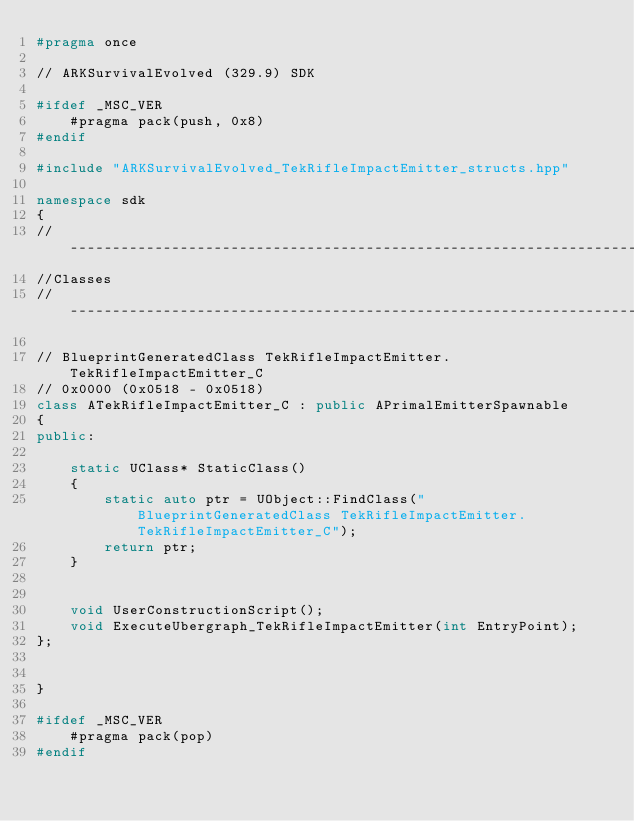Convert code to text. <code><loc_0><loc_0><loc_500><loc_500><_C++_>#pragma once

// ARKSurvivalEvolved (329.9) SDK

#ifdef _MSC_VER
	#pragma pack(push, 0x8)
#endif

#include "ARKSurvivalEvolved_TekRifleImpactEmitter_structs.hpp"

namespace sdk
{
//---------------------------------------------------------------------------
//Classes
//---------------------------------------------------------------------------

// BlueprintGeneratedClass TekRifleImpactEmitter.TekRifleImpactEmitter_C
// 0x0000 (0x0518 - 0x0518)
class ATekRifleImpactEmitter_C : public APrimalEmitterSpawnable
{
public:

	static UClass* StaticClass()
	{
		static auto ptr = UObject::FindClass("BlueprintGeneratedClass TekRifleImpactEmitter.TekRifleImpactEmitter_C");
		return ptr;
	}


	void UserConstructionScript();
	void ExecuteUbergraph_TekRifleImpactEmitter(int EntryPoint);
};


}

#ifdef _MSC_VER
	#pragma pack(pop)
#endif
</code> 